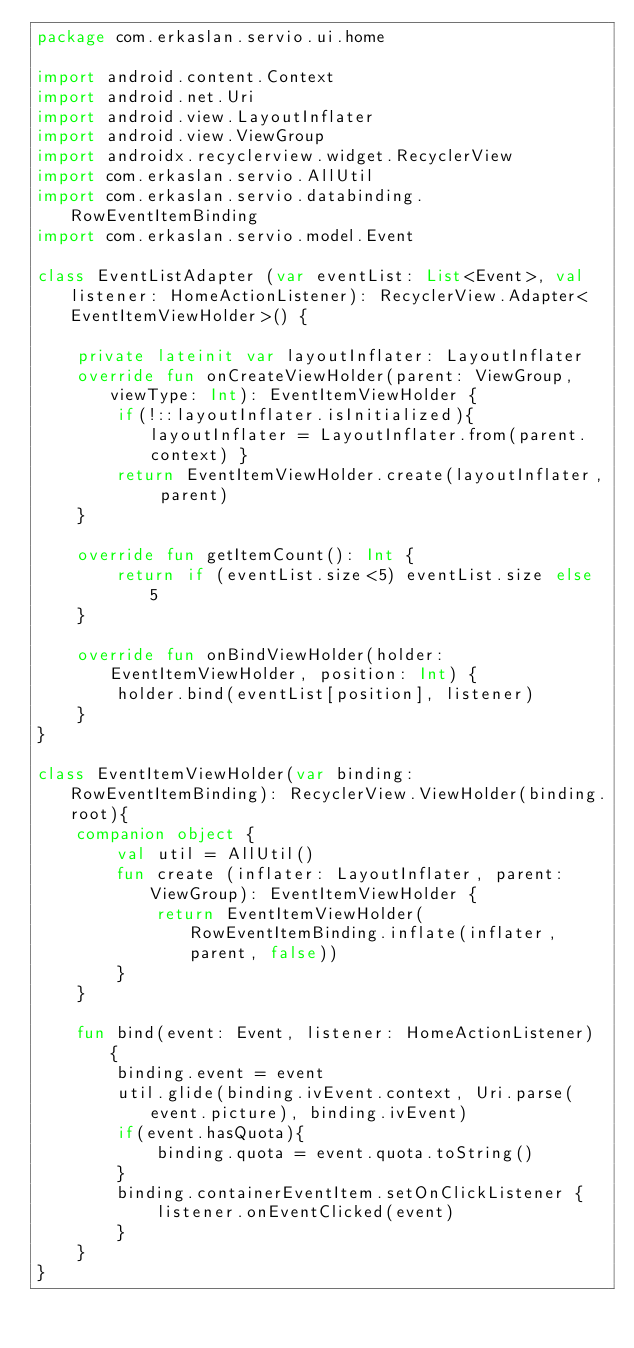<code> <loc_0><loc_0><loc_500><loc_500><_Kotlin_>package com.erkaslan.servio.ui.home

import android.content.Context
import android.net.Uri
import android.view.LayoutInflater
import android.view.ViewGroup
import androidx.recyclerview.widget.RecyclerView
import com.erkaslan.servio.AllUtil
import com.erkaslan.servio.databinding.RowEventItemBinding
import com.erkaslan.servio.model.Event

class EventListAdapter (var eventList: List<Event>, val listener: HomeActionListener): RecyclerView.Adapter<EventItemViewHolder>() {

    private lateinit var layoutInflater: LayoutInflater
    override fun onCreateViewHolder(parent: ViewGroup, viewType: Int): EventItemViewHolder {
        if(!::layoutInflater.isInitialized){ layoutInflater = LayoutInflater.from(parent.context) }
        return EventItemViewHolder.create(layoutInflater, parent)
    }

    override fun getItemCount(): Int {
        return if (eventList.size<5) eventList.size else 5
    }

    override fun onBindViewHolder(holder: EventItemViewHolder, position: Int) {
        holder.bind(eventList[position], listener)
    }
}

class EventItemViewHolder(var binding: RowEventItemBinding): RecyclerView.ViewHolder(binding.root){
    companion object {
        val util = AllUtil()
        fun create (inflater: LayoutInflater, parent: ViewGroup): EventItemViewHolder {
            return EventItemViewHolder(RowEventItemBinding.inflate(inflater, parent, false))
        }
    }

    fun bind(event: Event, listener: HomeActionListener) {
        binding.event = event
        util.glide(binding.ivEvent.context, Uri.parse(event.picture), binding.ivEvent)
        if(event.hasQuota){
            binding.quota = event.quota.toString()
        }
        binding.containerEventItem.setOnClickListener {
            listener.onEventClicked(event)
        }
    }
}</code> 